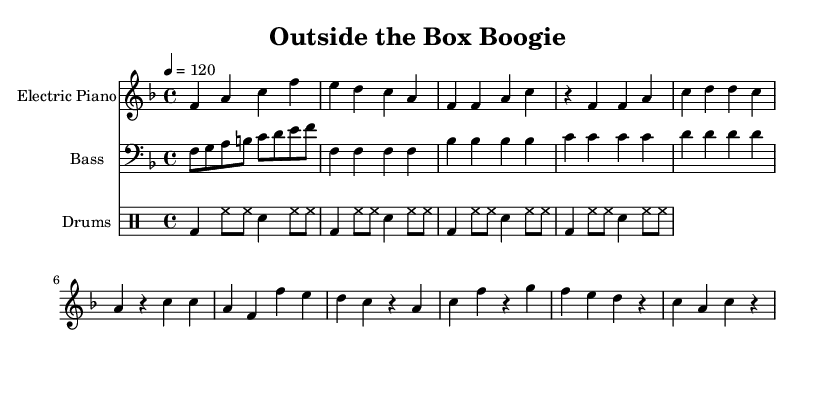What is the key signature of this music? The key signature is F major, which has one flat (B flat) indicated in the music.
Answer: F major What is the time signature of this music? The time signature is noted at the beginning of the score as 4/4, meaning there are four beats in a measure and the quarter note gets one beat.
Answer: 4/4 What is the tempo marking for this piece? The tempo marking is indicated by "4 = 120", which means there are 120 beats per minute, marking a moderate tempo for dancing.
Answer: 120 Which instrument plays the melody? The melody is played by the Electric Piano, as indicated by the instrument name in the staff title.
Answer: Electric Piano How many measures are in the Electric Piano part? Counting the measures in the Electric Piano part reveals there are 5 measures total.
Answer: 5 What type of rhythm pattern is used for the drums? The drums feature a consistent pattern of bass drum and hi-hat with a snare hit accent, typical of Disco music aimed at danceable beats.
Answer: Bass and hi-hat pattern What do the repeated notes in the bass line signify? The repeated notes in the bass line create a steady groove, common in Disco music, enhancing the dance feel and maintaining musical interest.
Answer: Steady groove 